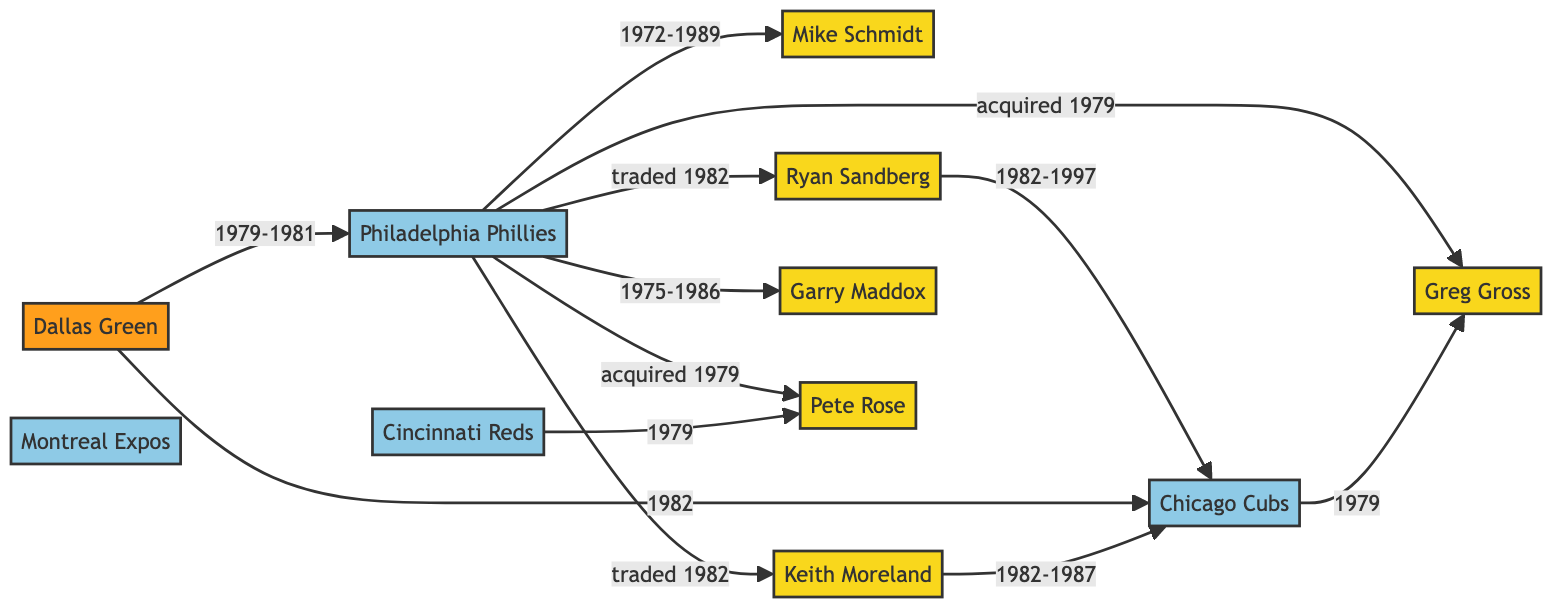What player was a part of the Phillies from 1972 to 1989? The relationship shows that Mike Schmidt was with the Philadelphia Phillies from 1972 to 1989. This is directly depicted in the diagram.
Answer: Mike Schmidt Which team did Ryan Sandberg get traded to in 1982? The diagram indicates that Ryan Sandberg was traded from the Philadelphia Phillies to the Chicago Cubs in 1982.
Answer: Chicago Cubs How many players were traded from the Phillies to the Cubs in 1982? Both Ryan Sandberg and Keith Moreland were traded from the Phillies to the Cubs in 1982, indicated by two edges leading to the Cubs.
Answer: 2 What year was Pete Rose acquired by the Phillies? According to the diagram, Pete Rose was acquired from the Cincinnati Reds in 1979 by the Philadelphia Phillies.
Answer: 1979 Who was the manager of the Phillies between 1979 and 1981? The diagram shows that Dallas Green was the manager of the Philadelphia Phillies during the years 1979 to 1981.
Answer: Dallas Green What was the relationship between the Phillies and Keith Moreland in 1982? The diagram specifies that the Phillies traded Keith Moreland to the Chicago Cubs in 1982, indicating a trade relationship at that time.
Answer: traded to Which player did the Phillies acquire from the Cubs in 1979? The diagram indicates that Greg Gross was acquired from the Chicago Cubs by the Philadelphia Phillies in 1979.
Answer: Greg Gross Who became the manager of the Cubs in 1982? The diagram shows that Dallas Green became the manager of the Chicago Cubs in 1982 after managing the Phillies from 1979 to 1981.
Answer: Dallas Green What relationship did Garry Maddox have with the Phillies? According to the diagram, Garry Maddox was part of the Philadelphia Phillies from 1975 to 1986, indicating a long-term relationship.
Answer: was part of 